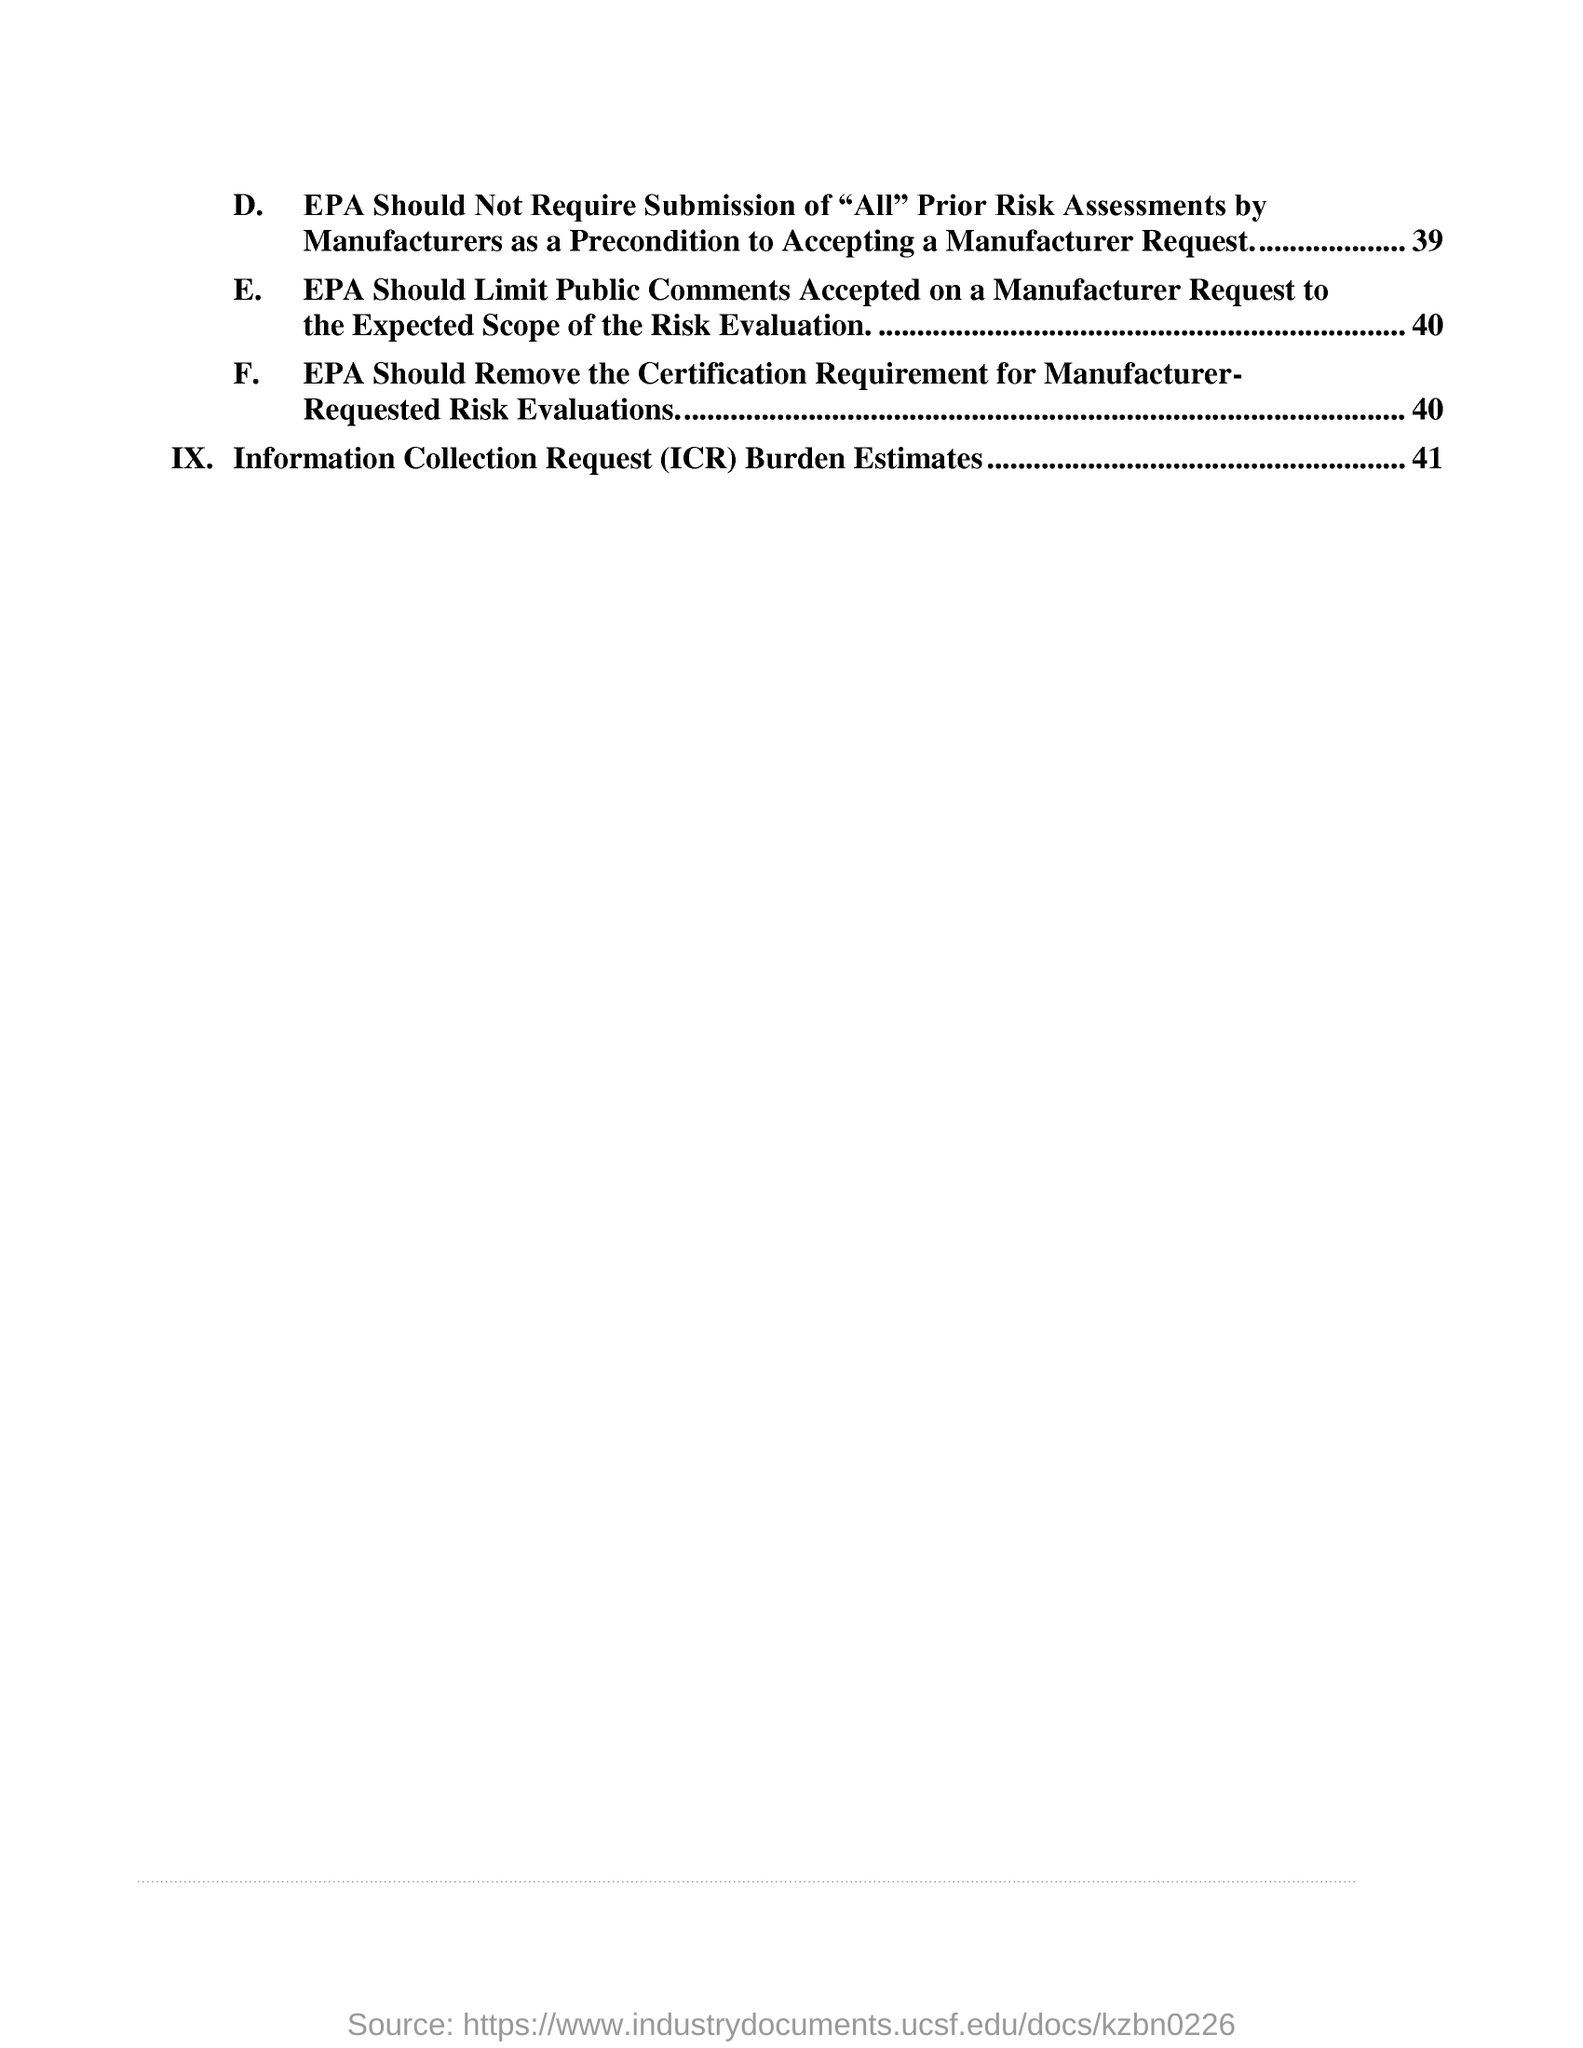Outline some significant characteristics in this image. The fullform of ICR is "Information Collection Request. 